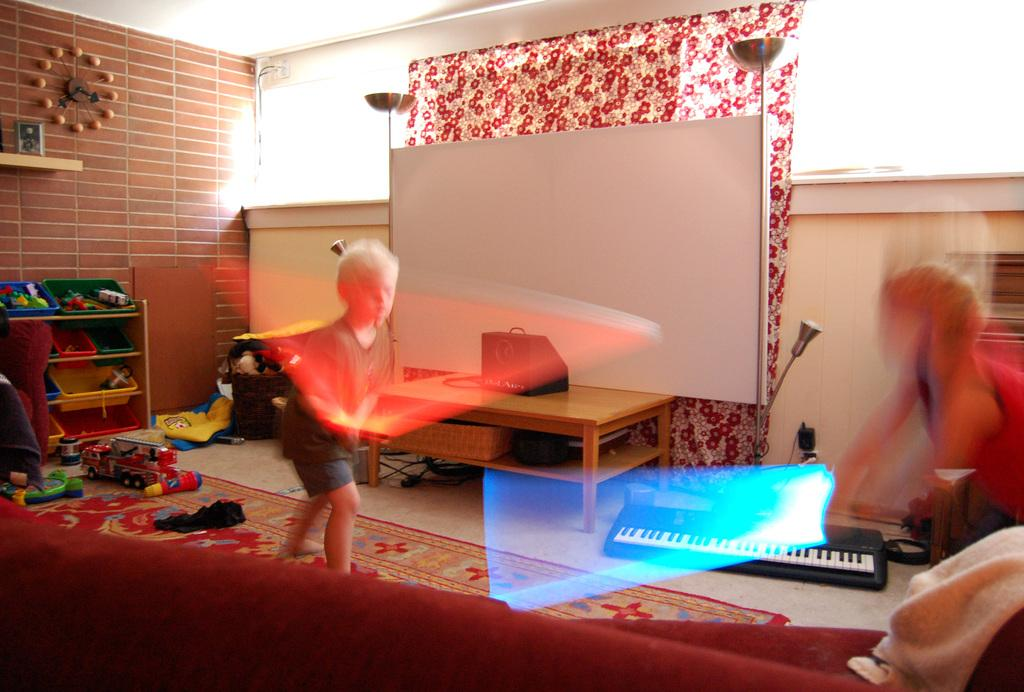How many children are present in the image? There are two boys in the image. What are the boys doing in the image? The boys are playing with toys. Where is the scene taking place? The setting is a living room. What type of quince can be seen in the image? There is no quince present in the image. What question are the boys asking each other while playing with toys? The provided facts do not mention any questions being asked by the boys, so we cannot answer this question. 